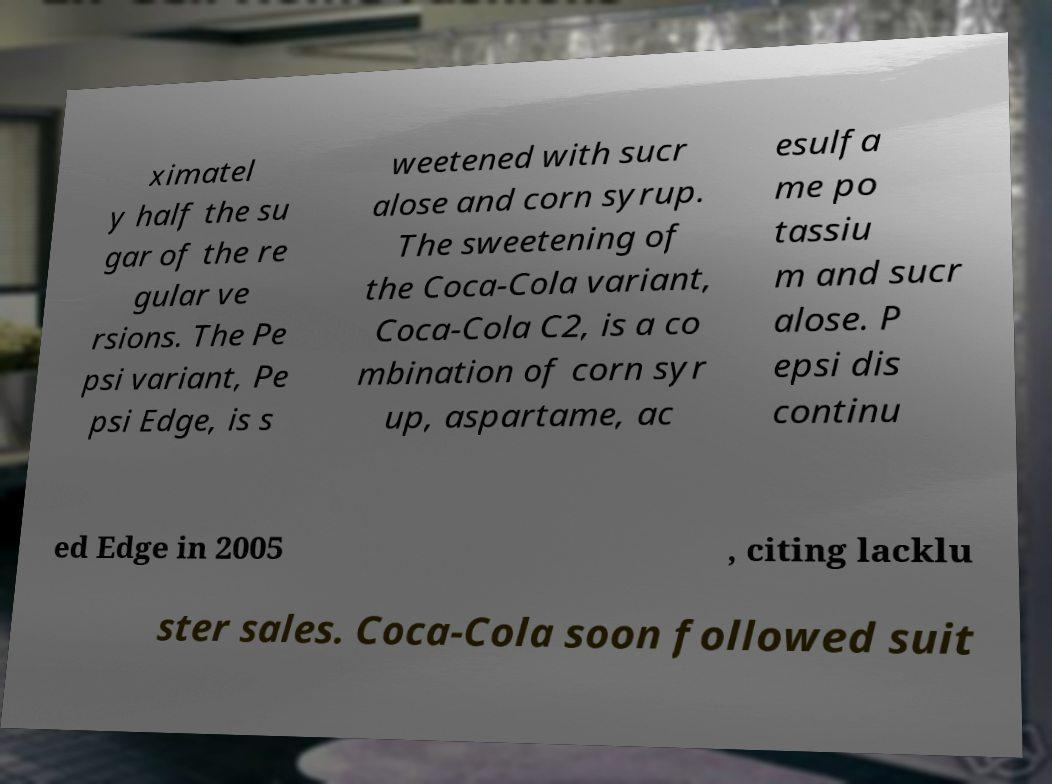Could you assist in decoding the text presented in this image and type it out clearly? ximatel y half the su gar of the re gular ve rsions. The Pe psi variant, Pe psi Edge, is s weetened with sucr alose and corn syrup. The sweetening of the Coca-Cola variant, Coca-Cola C2, is a co mbination of corn syr up, aspartame, ac esulfa me po tassiu m and sucr alose. P epsi dis continu ed Edge in 2005 , citing lacklu ster sales. Coca-Cola soon followed suit 